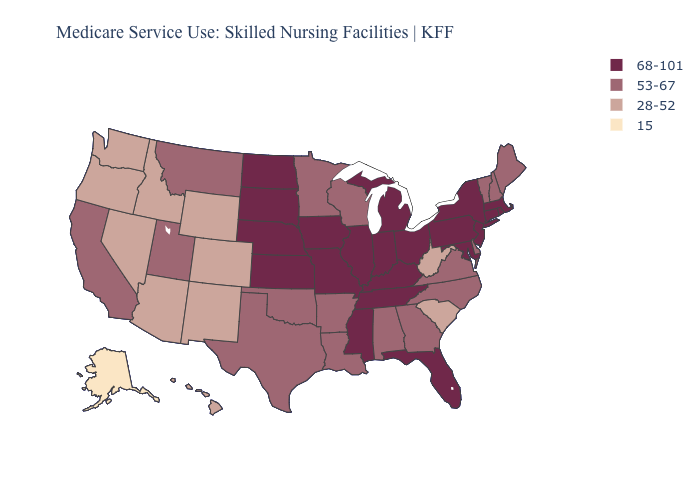Does the first symbol in the legend represent the smallest category?
Be succinct. No. Which states have the lowest value in the West?
Be succinct. Alaska. Does West Virginia have the same value as Florida?
Answer briefly. No. Is the legend a continuous bar?
Concise answer only. No. What is the value of North Dakota?
Quick response, please. 68-101. Does New Jersey have the highest value in the USA?
Short answer required. Yes. What is the value of Texas?
Answer briefly. 53-67. Does Alaska have the lowest value in the USA?
Give a very brief answer. Yes. Name the states that have a value in the range 68-101?
Keep it brief. Connecticut, Florida, Illinois, Indiana, Iowa, Kansas, Kentucky, Maryland, Massachusetts, Michigan, Mississippi, Missouri, Nebraska, New Jersey, New York, North Dakota, Ohio, Pennsylvania, Rhode Island, South Dakota, Tennessee. What is the lowest value in the South?
Quick response, please. 28-52. Name the states that have a value in the range 53-67?
Be succinct. Alabama, Arkansas, California, Delaware, Georgia, Louisiana, Maine, Minnesota, Montana, New Hampshire, North Carolina, Oklahoma, Texas, Utah, Vermont, Virginia, Wisconsin. Name the states that have a value in the range 53-67?
Be succinct. Alabama, Arkansas, California, Delaware, Georgia, Louisiana, Maine, Minnesota, Montana, New Hampshire, North Carolina, Oklahoma, Texas, Utah, Vermont, Virginia, Wisconsin. What is the lowest value in states that border Minnesota?
Give a very brief answer. 53-67. Does New Hampshire have the highest value in the Northeast?
Answer briefly. No. What is the value of Idaho?
Concise answer only. 28-52. 